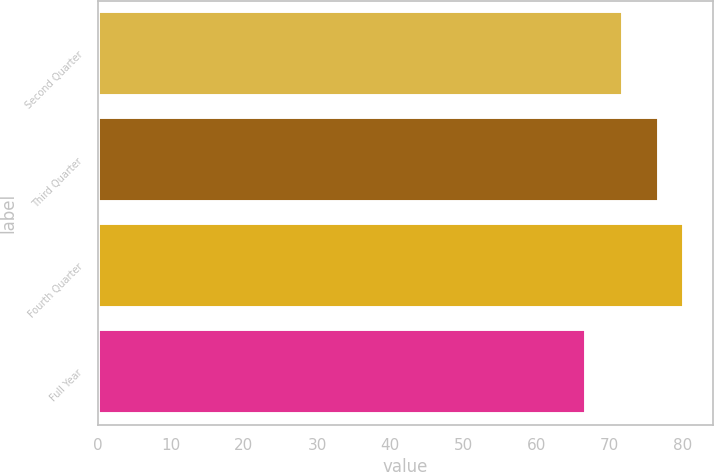Convert chart. <chart><loc_0><loc_0><loc_500><loc_500><bar_chart><fcel>Second Quarter<fcel>Third Quarter<fcel>Fourth Quarter<fcel>Full Year<nl><fcel>71.79<fcel>76.68<fcel>80.12<fcel>66.75<nl></chart> 